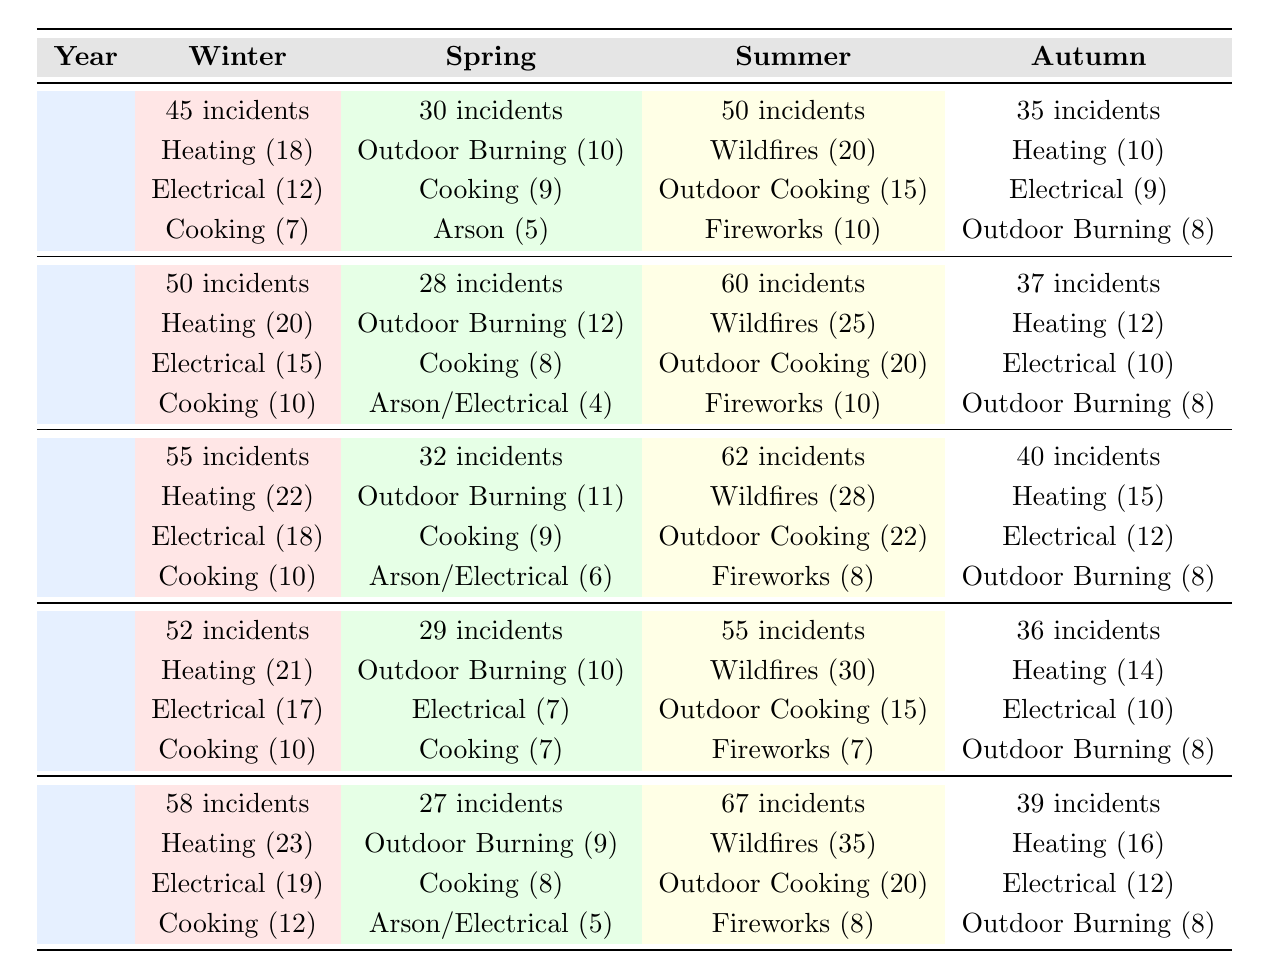What was the top cause of fire incidents in Winter for the year 2022? In Winter 2022, the top cause of fire incidents was Heating Equipment with 21 incidents reported, as listed in the table.
Answer: Heating Equipment Which season had the highest number of fire incidents in 2021? In 2021, Summer had the highest number of fire incidents with 62 incidents, compared to Winter (55), Spring (32), and Autumn (40).
Answer: Summer What is the average number of incidents for Spring over the five years? The Spring incident counts are 30 (2019), 28 (2020), 32 (2021), 29 (2022), and 27 (2023). Adding these gives 30 + 28 + 32 + 29 + 27 = 146. Dividing by 5 gives an average of 146/5 = 29.2.
Answer: 29.2 Did the total number of fire incidents increase from 2019 to 2023? Summing the incidents from each year: 2019 (160), 2020 (175), 2021 (189), 2022 (172), and 2023 (191). The total increased from 160 in 2019 to 191 in 2023, showing an increase of 31 incidents.
Answer: Yes Which season had the least number of incidents in 2020? In 2020, Spring had the least number of incidents with 28, compared to Winter (50), Summer (60), and Autumn (37).
Answer: Spring 